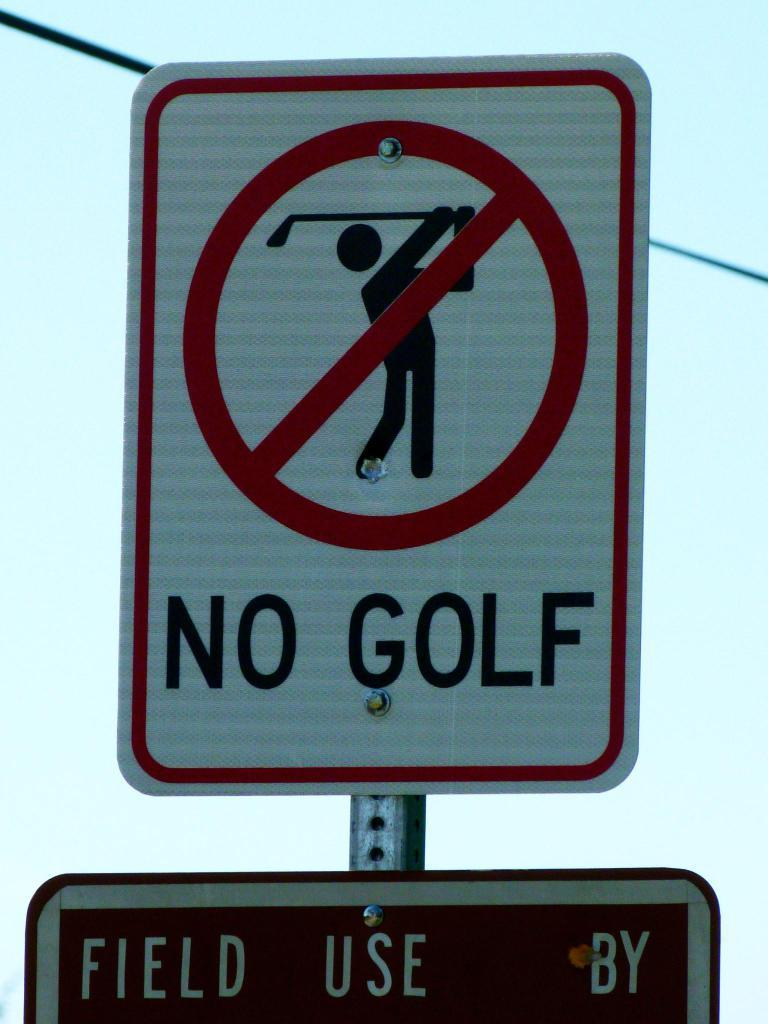<image>
Offer a succinct explanation of the picture presented. Red and white street sign that says No Golf. 